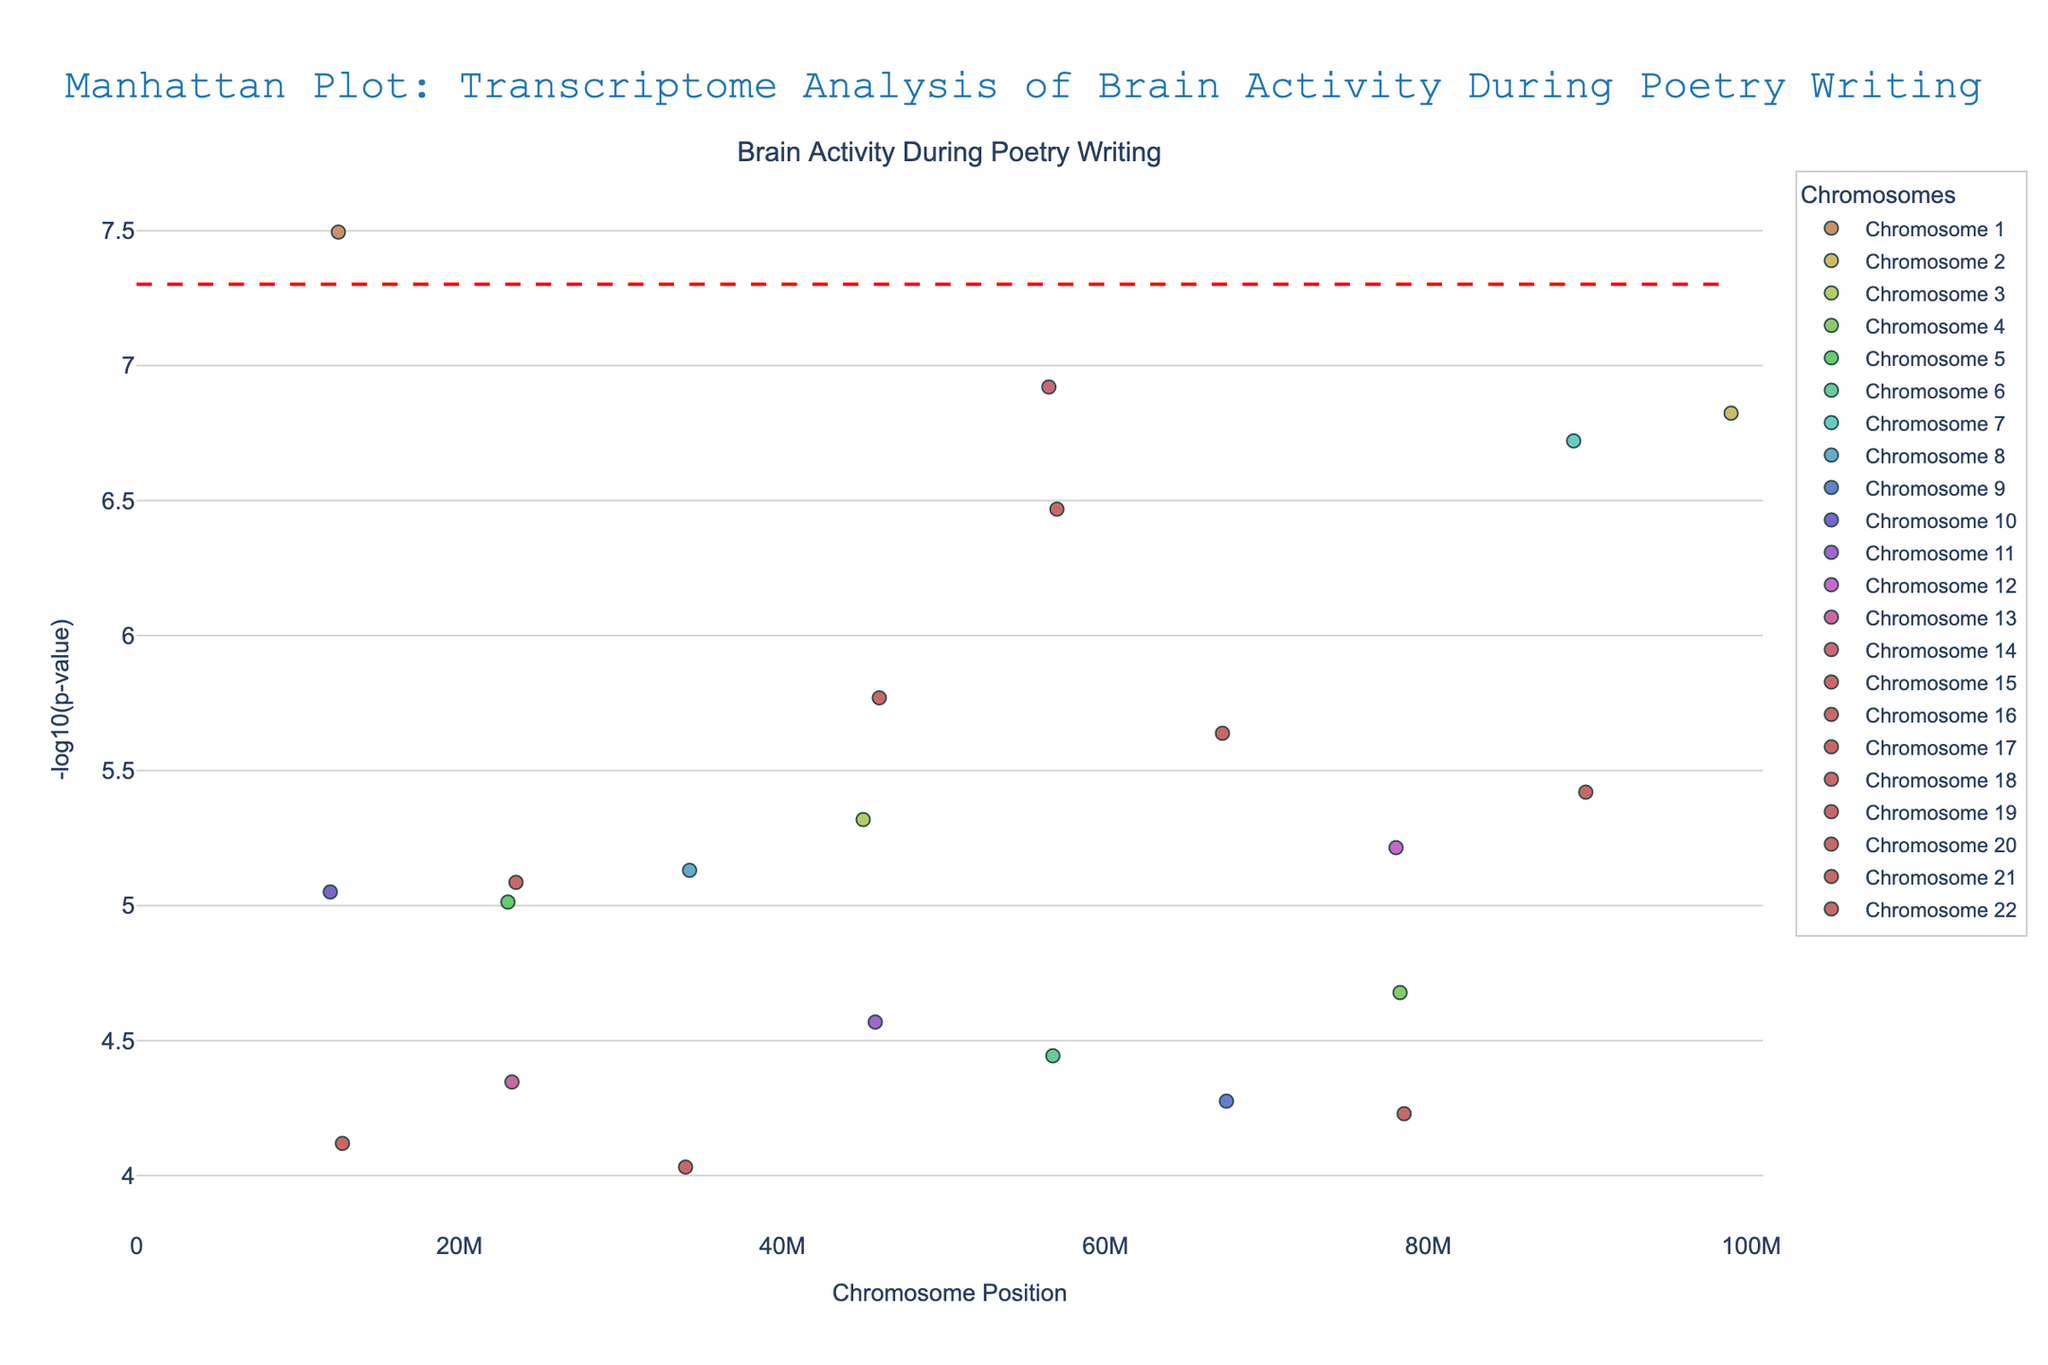What is the title of the Manhattan plot? The title is displayed at the top of the figure and reads "Manhattan Plot: Transcriptome Analysis of Brain Activity During Poetry Writing".
Answer: Manhattan Plot: Transcriptome Analysis of Brain Activity During Poetry Writing Which gene has the smallest p-value? The smallest p-value will correspond to the highest point on the y-axis since the y-axis shows -log10(p-value). The gene with the smallest p-value is FOXP2.
Answer: FOXP2 How many chromosomes are represented in the plot? Each different color and legend entry represents a different chromosome. There are 22 unique chromosomes listed in the legend.
Answer: 22 Which chromosome shows the most significant gene expression? Significance in a Manhattan plot is indicated by points farthest up the y-axis. Chromosome 1 (FOXP2) has the most significant gene expression.
Answer: Chromosome 1 How many genes exceed the significance threshold line? The significance threshold line is represented by the red dashed line. There are 4 gene points above this line.
Answer: 4 What is the chromosomal position of the gene NRXN3? Hovering over the data point near the y-axis value corresponding to NRXN3 shows the x-axis position it falls on, which is labeled as 46000000.
Answer: 46000000 Compare the p-values of genes BDNF and SLC6A4, which one is more significant? In the Manhattan plot, higher points show smaller p-values, hence more significant. SLC6A4 has a higher y-axis value (-log10(p)) than BDNF.
Answer: SLC6A4 What is the significance threshold used in the plot? The significance threshold is represented by the horizontal red dashed line. Hovering over the line may show the value, or you can calculate -log10(5e-8). The significance threshold p-value is 5e-8.
Answer: 5e-8 Which gene on chromosome 22 has been highlighted in the plot? By looking at the points labeled under chromosome 22, the gene above the significance threshold is SNAP25.
Answer: SNAP25 